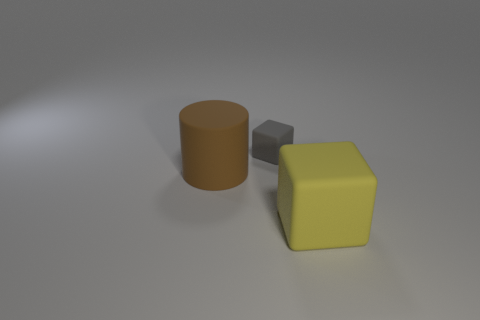Add 2 gray cubes. How many objects exist? 5 Subtract all blocks. How many objects are left? 1 Subtract 0 cyan cylinders. How many objects are left? 3 Subtract all small green metallic objects. Subtract all big things. How many objects are left? 1 Add 1 big brown rubber cylinders. How many big brown rubber cylinders are left? 2 Add 1 small things. How many small things exist? 2 